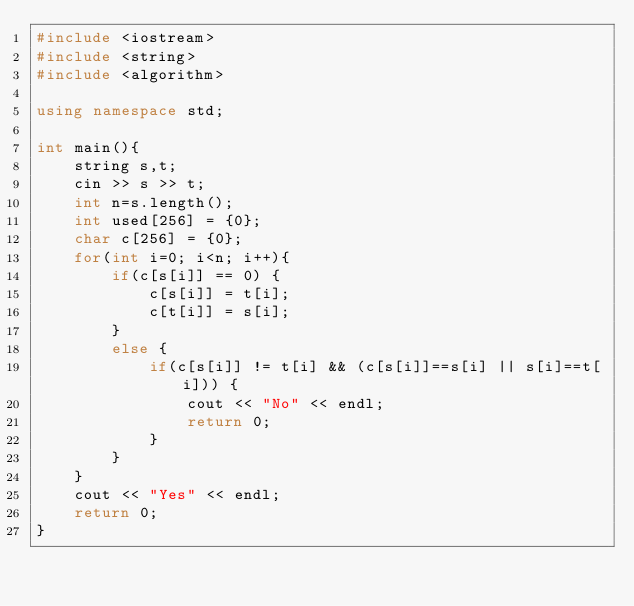Convert code to text. <code><loc_0><loc_0><loc_500><loc_500><_C++_>#include <iostream>
#include <string>
#include <algorithm>

using namespace std;

int main(){
    string s,t;
    cin >> s >> t;
    int n=s.length();
    int used[256] = {0};
    char c[256] = {0};
    for(int i=0; i<n; i++){
        if(c[s[i]] == 0) {
            c[s[i]] = t[i];
            c[t[i]] = s[i];
        }
        else {
            if(c[s[i]] != t[i] && (c[s[i]]==s[i] || s[i]==t[i])) {
                cout << "No" << endl;
                return 0;
            }
        }
    }
    cout << "Yes" << endl;
    return 0;
}

</code> 